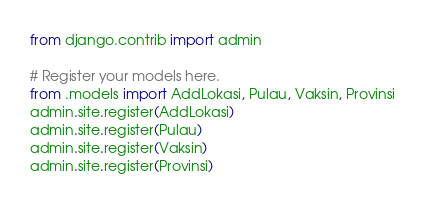Convert code to text. <code><loc_0><loc_0><loc_500><loc_500><_Python_>from django.contrib import admin

# Register your models here.
from .models import AddLokasi, Pulau, Vaksin, Provinsi
admin.site.register(AddLokasi)
admin.site.register(Pulau)
admin.site.register(Vaksin)
admin.site.register(Provinsi)</code> 